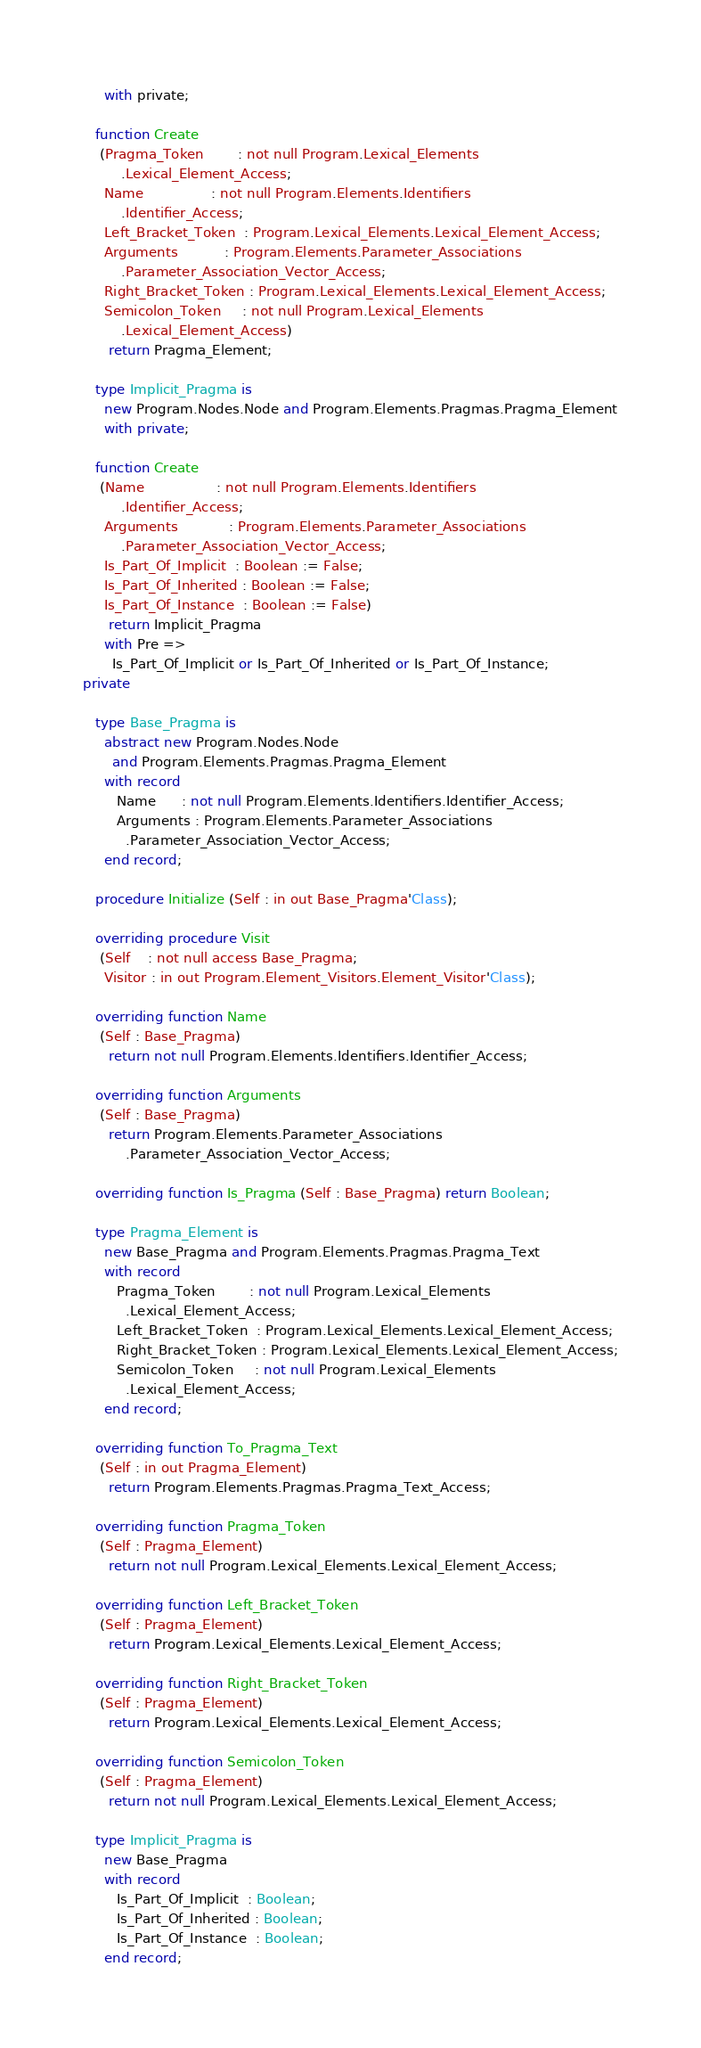Convert code to text. <code><loc_0><loc_0><loc_500><loc_500><_Ada_>     with private;

   function Create
    (Pragma_Token        : not null Program.Lexical_Elements
         .Lexical_Element_Access;
     Name                : not null Program.Elements.Identifiers
         .Identifier_Access;
     Left_Bracket_Token  : Program.Lexical_Elements.Lexical_Element_Access;
     Arguments           : Program.Elements.Parameter_Associations
         .Parameter_Association_Vector_Access;
     Right_Bracket_Token : Program.Lexical_Elements.Lexical_Element_Access;
     Semicolon_Token     : not null Program.Lexical_Elements
         .Lexical_Element_Access)
      return Pragma_Element;

   type Implicit_Pragma is
     new Program.Nodes.Node and Program.Elements.Pragmas.Pragma_Element
     with private;

   function Create
    (Name                 : not null Program.Elements.Identifiers
         .Identifier_Access;
     Arguments            : Program.Elements.Parameter_Associations
         .Parameter_Association_Vector_Access;
     Is_Part_Of_Implicit  : Boolean := False;
     Is_Part_Of_Inherited : Boolean := False;
     Is_Part_Of_Instance  : Boolean := False)
      return Implicit_Pragma
     with Pre =>
       Is_Part_Of_Implicit or Is_Part_Of_Inherited or Is_Part_Of_Instance;
private

   type Base_Pragma is
     abstract new Program.Nodes.Node
       and Program.Elements.Pragmas.Pragma_Element
     with record
        Name      : not null Program.Elements.Identifiers.Identifier_Access;
        Arguments : Program.Elements.Parameter_Associations
          .Parameter_Association_Vector_Access;
     end record;

   procedure Initialize (Self : in out Base_Pragma'Class);

   overriding procedure Visit
    (Self    : not null access Base_Pragma;
     Visitor : in out Program.Element_Visitors.Element_Visitor'Class);

   overriding function Name
    (Self : Base_Pragma)
      return not null Program.Elements.Identifiers.Identifier_Access;

   overriding function Arguments
    (Self : Base_Pragma)
      return Program.Elements.Parameter_Associations
          .Parameter_Association_Vector_Access;

   overriding function Is_Pragma (Self : Base_Pragma) return Boolean;

   type Pragma_Element is
     new Base_Pragma and Program.Elements.Pragmas.Pragma_Text
     with record
        Pragma_Token        : not null Program.Lexical_Elements
          .Lexical_Element_Access;
        Left_Bracket_Token  : Program.Lexical_Elements.Lexical_Element_Access;
        Right_Bracket_Token : Program.Lexical_Elements.Lexical_Element_Access;
        Semicolon_Token     : not null Program.Lexical_Elements
          .Lexical_Element_Access;
     end record;

   overriding function To_Pragma_Text
    (Self : in out Pragma_Element)
      return Program.Elements.Pragmas.Pragma_Text_Access;

   overriding function Pragma_Token
    (Self : Pragma_Element)
      return not null Program.Lexical_Elements.Lexical_Element_Access;

   overriding function Left_Bracket_Token
    (Self : Pragma_Element)
      return Program.Lexical_Elements.Lexical_Element_Access;

   overriding function Right_Bracket_Token
    (Self : Pragma_Element)
      return Program.Lexical_Elements.Lexical_Element_Access;

   overriding function Semicolon_Token
    (Self : Pragma_Element)
      return not null Program.Lexical_Elements.Lexical_Element_Access;

   type Implicit_Pragma is
     new Base_Pragma
     with record
        Is_Part_Of_Implicit  : Boolean;
        Is_Part_Of_Inherited : Boolean;
        Is_Part_Of_Instance  : Boolean;
     end record;
</code> 